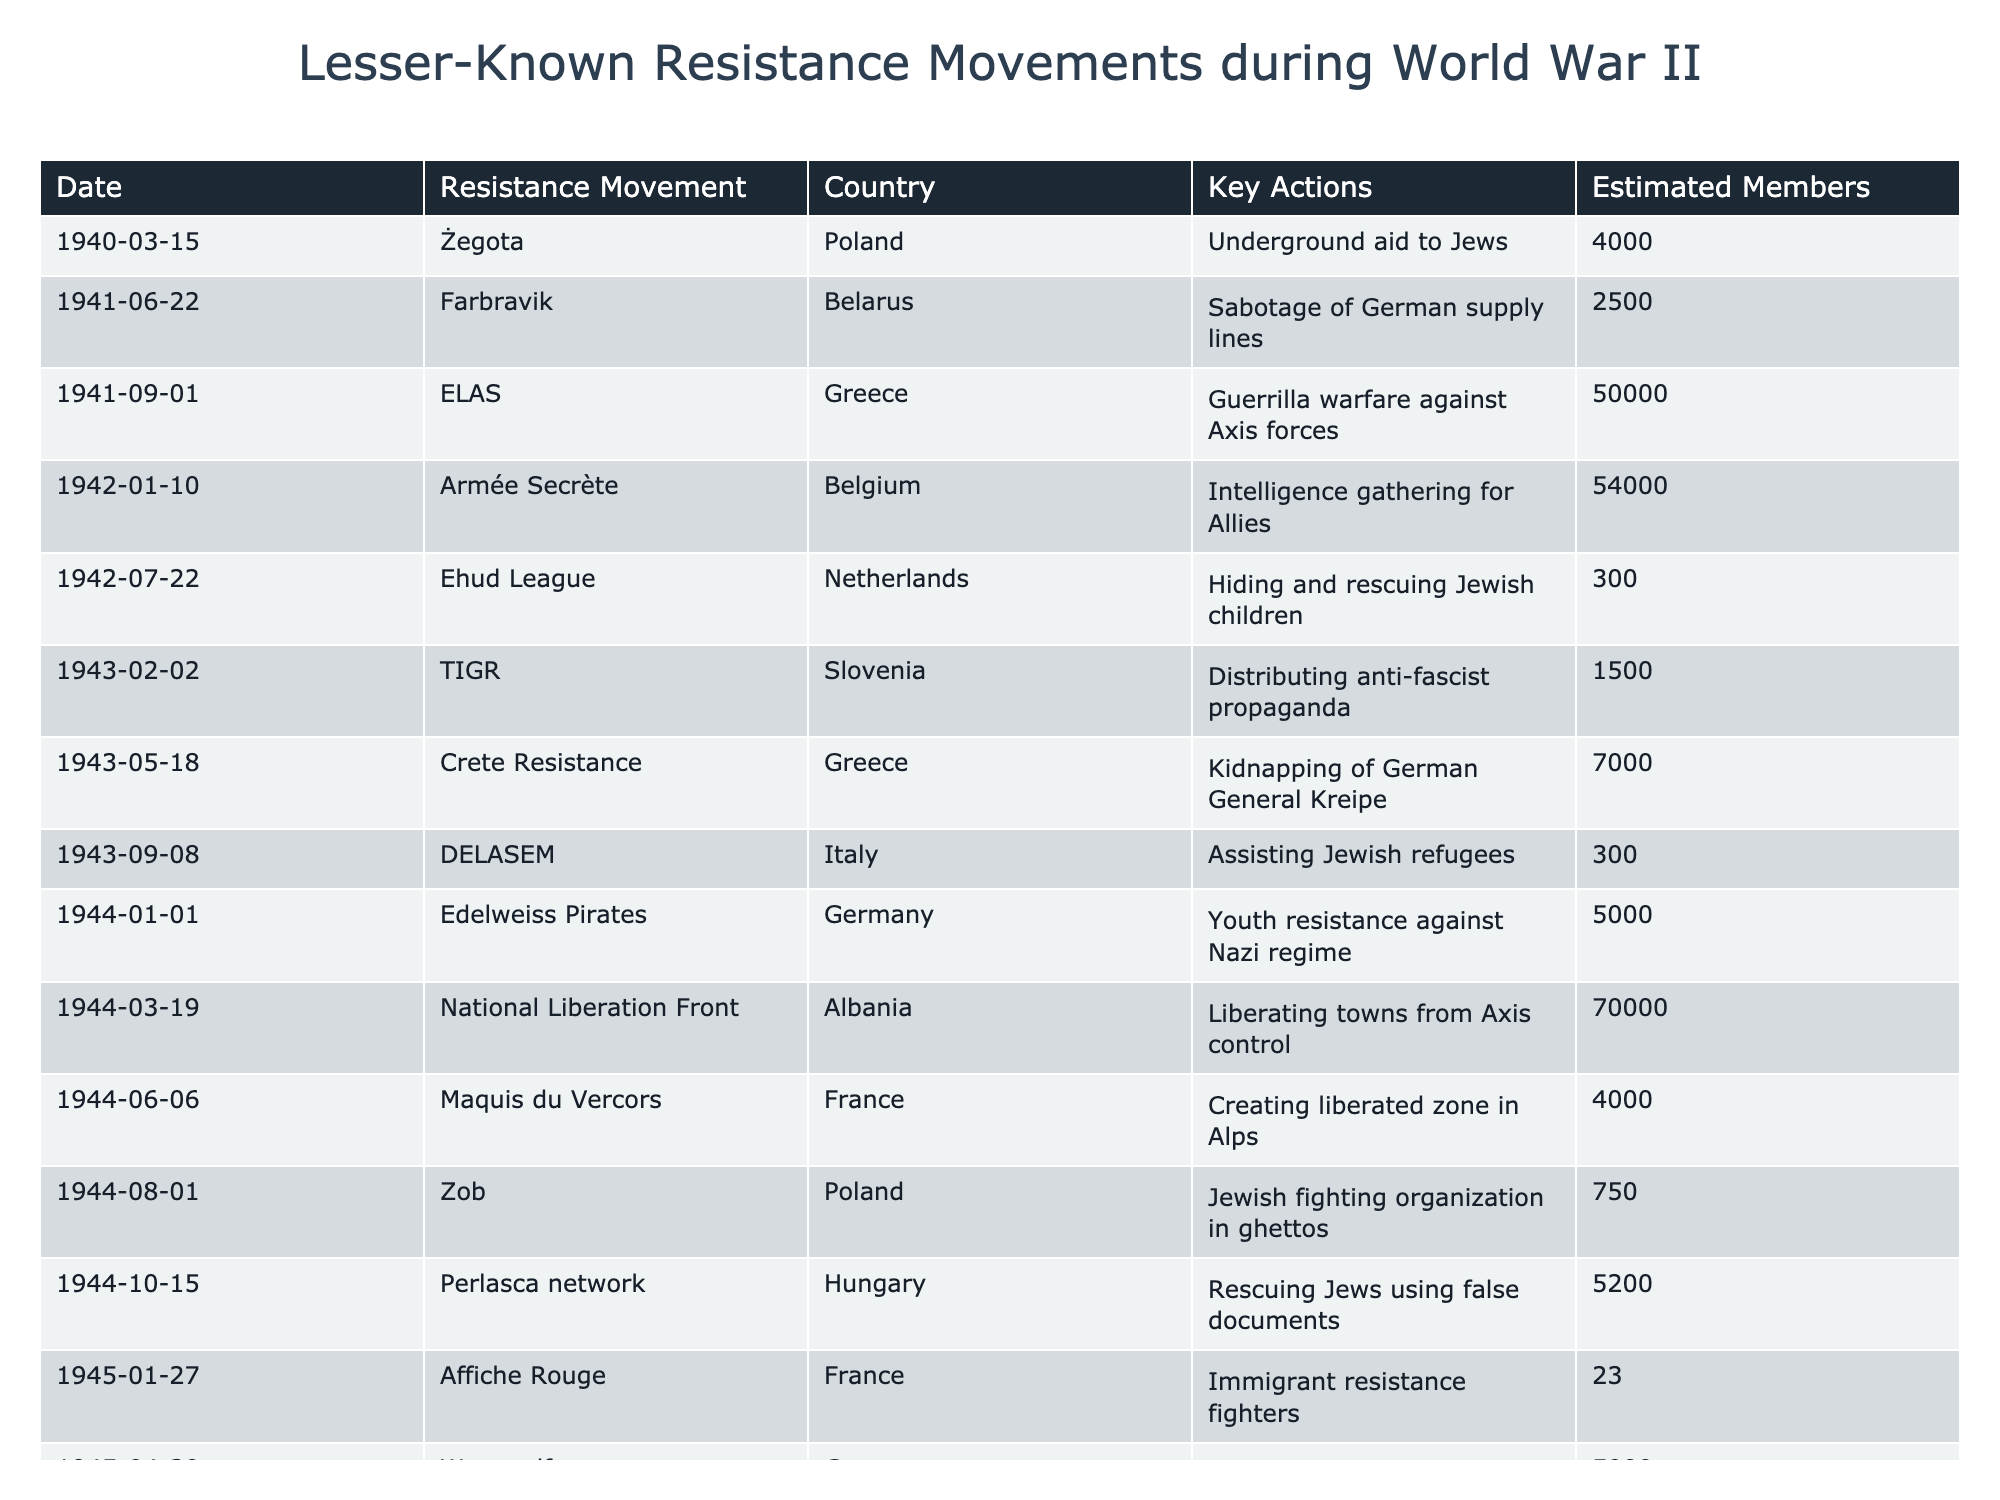What was the largest resistance movement in terms of estimated members? By checking the "Estimated Members" column, we see that ELAS in Greece has the highest estimated membership with 50,000 participants.
Answer: 50,000 Which resistance movement involved sabotaging German supply lines? In the "Key Actions" column, "Sabotage of German supply lines" corresponds to the Farbravik movement from Belarus, which started on June 22, 1941.
Answer: Farbravik What is the total number of estimated members in all resistance movements listed from Poland? The estimated members for Żegota (4000) and Zob (750) are relevant. We sum these to get 4000 + 750 = 4750.
Answer: 4750 Did any of the resistance movements listed take place after 1944? Yes, the Werewolf movement in Germany occurred on April 30, 1945, indicating resistance activities that extended beyond 1944.
Answer: Yes What percentage of the total estimated members (who are part of the listed resistance movements) belonged to the Armée Secrète? First, we calculate the total estimated members from the table, which is 50,000 + 54,000 + 4,000 + 7,000 + 5,000 + ... + 23 = 96,073. The membership of the Armée Secrète is 54,000. Thus, the percentage is (54,000 / 96,073) * 100 ≈ 56.17%.
Answer: Approximately 56.17% Which country had the least estimated members involved in a resistance movement based on the table? By comparing the "Estimated Members" values, we see that the Affiche Rouge in France had the lowest estimated membership with only 23 members.
Answer: France What was a key action of the Maquis du Vercors according to the table? The "Key Actions" column shows that the Maquis du Vercors created a liberated zone in the Alps, which was one of their main actions.
Answer: Creating liberated zone in Alps How many resistance movements listed were specifically focused on aiding Jewish people? The resistance movements that focused on aiding Jewish people include Żegota, Ehud League, DELASEM, and Perlasca network. This totals four movements.
Answer: 4 What is the difference in estimated members between the National Liberation Front and the Edelweiss Pirates? The National Liberation Front has 70,000 members while the Edelweiss Pirates have 5,000. The difference is 70,000 - 5,000 = 65,000.
Answer: 65,000 Which country had multiple resistance movements listed and what are the names of those movements? Poland had multiple movements with Żegota and Zob being the two listed.
Answer: Żegota and Zob Did the resistance movement called TIGR primarily engage in guerrilla warfare? No, the TIGR movement in Slovenia was engaged in distributing anti-fascist propaganda, not guerrilla warfare.
Answer: No 